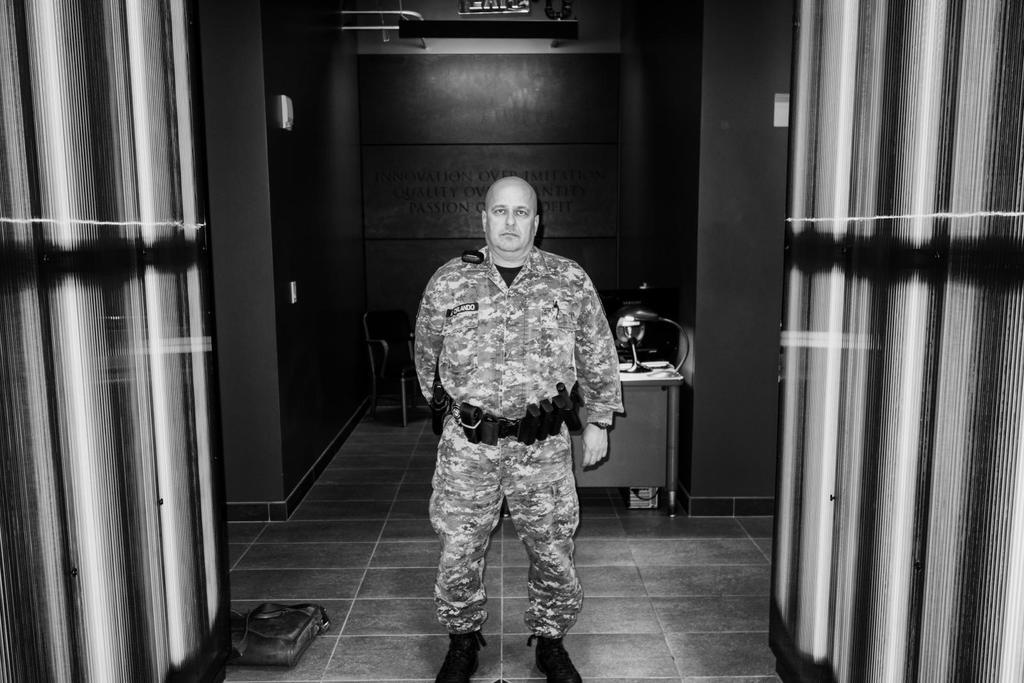Who is present in the image? There is a man in the image. What is the man wearing? The man is wearing an army dress. What object can be seen behind the man? There is a lamp behind the man. What type of background is visible in the image? There is a wall visible in the image. What type of trail can be seen in the image? There is no trail present in the image. What is the man doing with the waste in the image? There is no waste present in the image, and the man's actions are not described. 